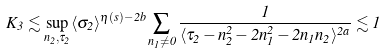Convert formula to latex. <formula><loc_0><loc_0><loc_500><loc_500>K _ { 3 } \lesssim \sup _ { n _ { 2 } , \tau _ { 2 } } \langle \sigma _ { 2 } \rangle ^ { \eta ( s ) - 2 b } \sum _ { n _ { 1 } \neq 0 } \frac { 1 } { \langle \tau _ { 2 } - n _ { 2 } ^ { 2 } - 2 n _ { 1 } ^ { 2 } - 2 n _ { 1 } n _ { 2 } \rangle ^ { 2 a } } \lesssim 1</formula> 